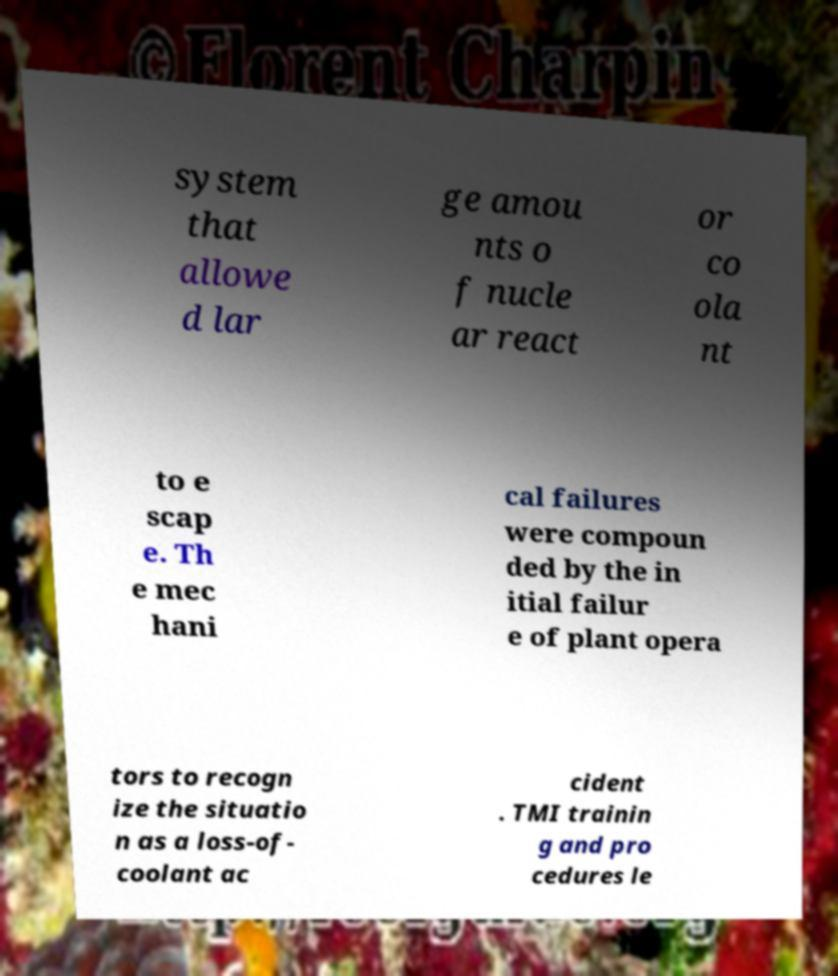Could you assist in decoding the text presented in this image and type it out clearly? system that allowe d lar ge amou nts o f nucle ar react or co ola nt to e scap e. Th e mec hani cal failures were compoun ded by the in itial failur e of plant opera tors to recogn ize the situatio n as a loss-of- coolant ac cident . TMI trainin g and pro cedures le 